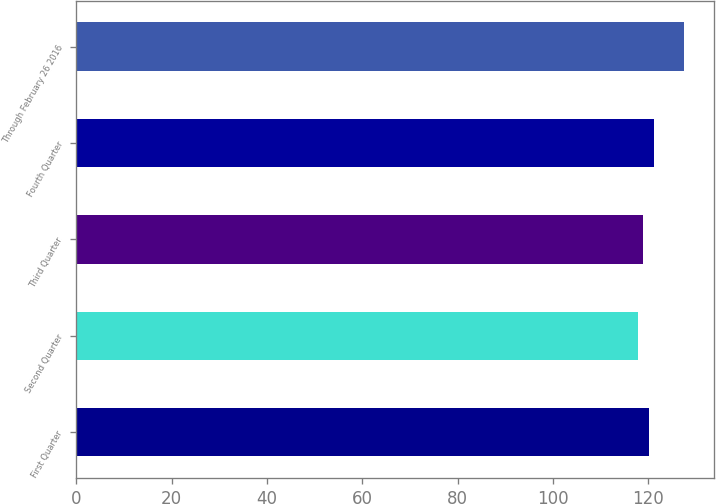<chart> <loc_0><loc_0><loc_500><loc_500><bar_chart><fcel>First Quarter<fcel>Second Quarter<fcel>Third Quarter<fcel>Fourth Quarter<fcel>Through February 26 2016<nl><fcel>120.21<fcel>117.85<fcel>118.81<fcel>121.17<fcel>127.44<nl></chart> 